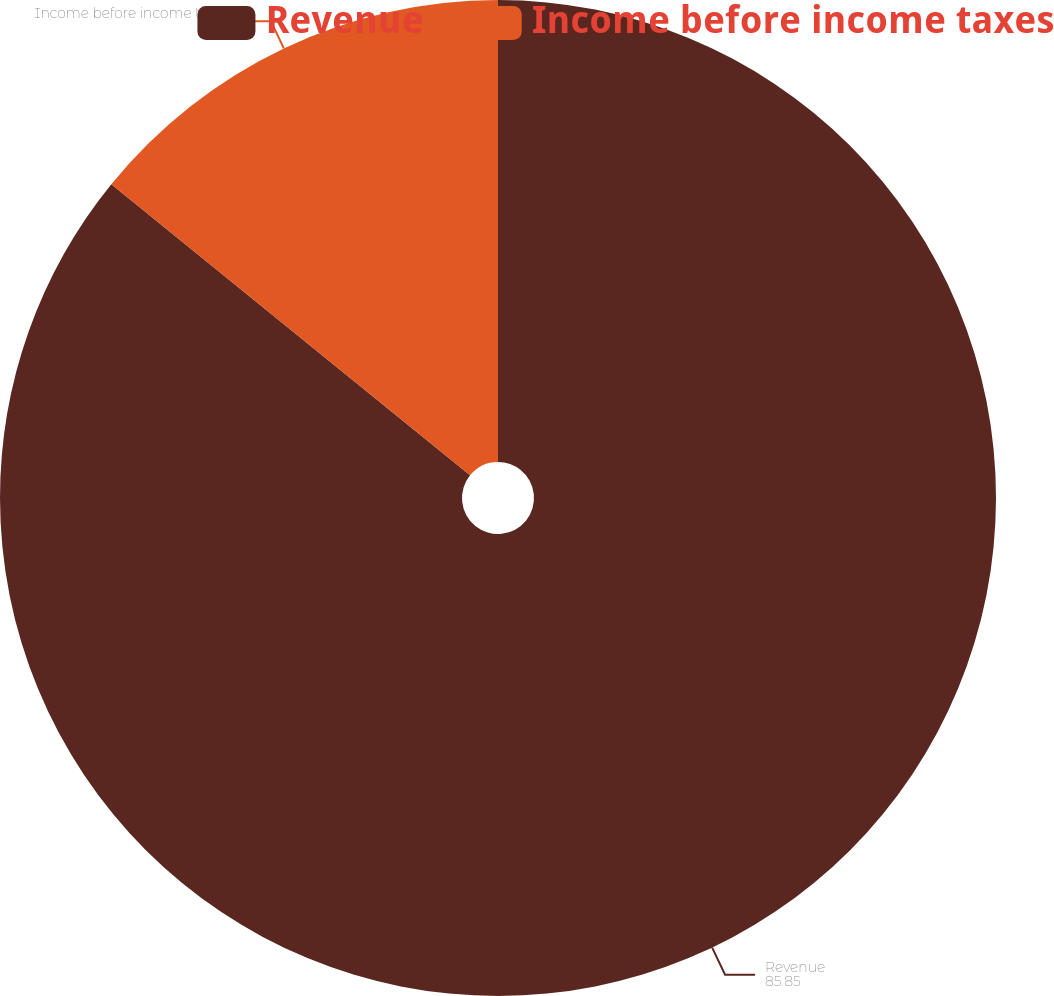Convert chart to OTSL. <chart><loc_0><loc_0><loc_500><loc_500><pie_chart><fcel>Revenue<fcel>Income before income taxes<nl><fcel>85.85%<fcel>14.15%<nl></chart> 